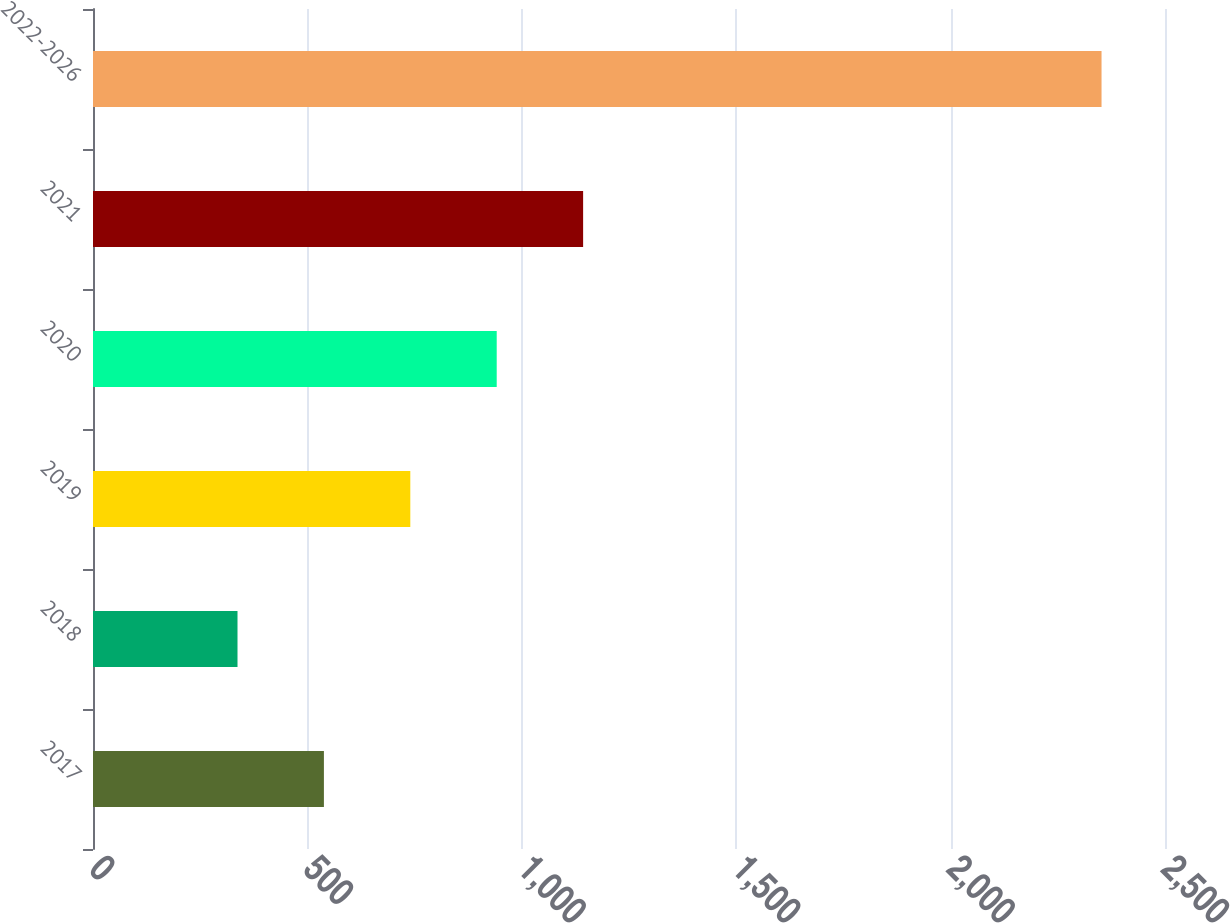Convert chart. <chart><loc_0><loc_0><loc_500><loc_500><bar_chart><fcel>2017<fcel>2018<fcel>2019<fcel>2020<fcel>2021<fcel>2022-2026<nl><fcel>538.5<fcel>337<fcel>740<fcel>941.5<fcel>1143<fcel>2352<nl></chart> 